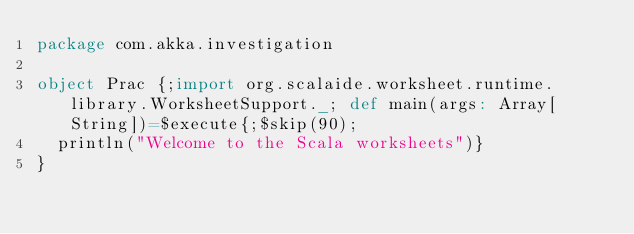Convert code to text. <code><loc_0><loc_0><loc_500><loc_500><_Scala_>package com.akka.investigation

object Prac {;import org.scalaide.worksheet.runtime.library.WorksheetSupport._; def main(args: Array[String])=$execute{;$skip(90); 
  println("Welcome to the Scala worksheets")}
}
</code> 